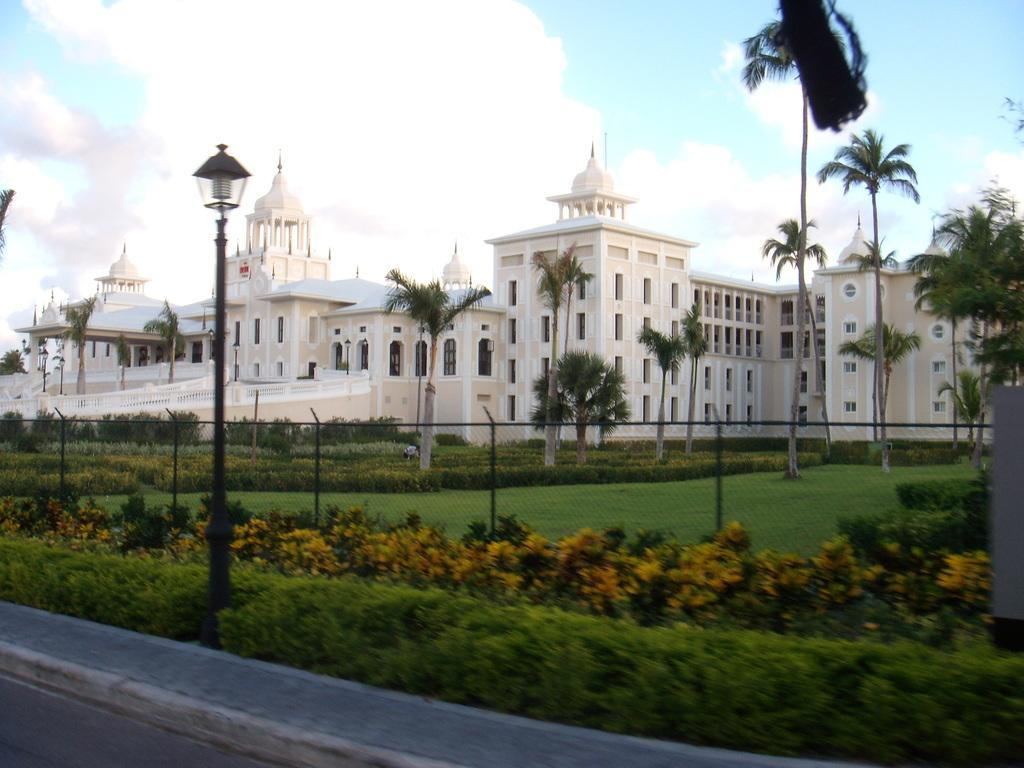What type of structures can be seen in the image? There are buildings in the image. What type of vegetation is present in the image? There are trees, bushes, shrubs, and flowers visible in the image. What other objects can be seen in the image? There is a pole and a fence in the image. What is visible at the top of the image? The sky is visible at the top of the image. What type of ground cover is present in the image? Grass is present in the image. Where is the soap located in the image? There is no soap present in the image. How many feet are visible in the image? There are no feet visible in the image. 